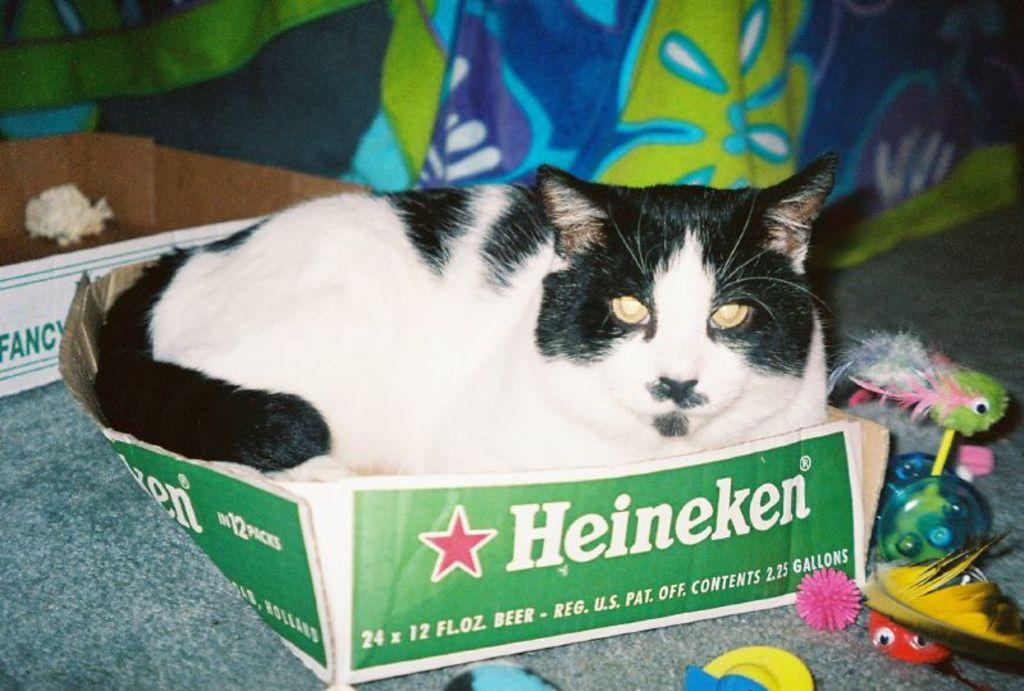<image>
Share a concise interpretation of the image provided. A black and white cat sits in a Heineken beer box. 